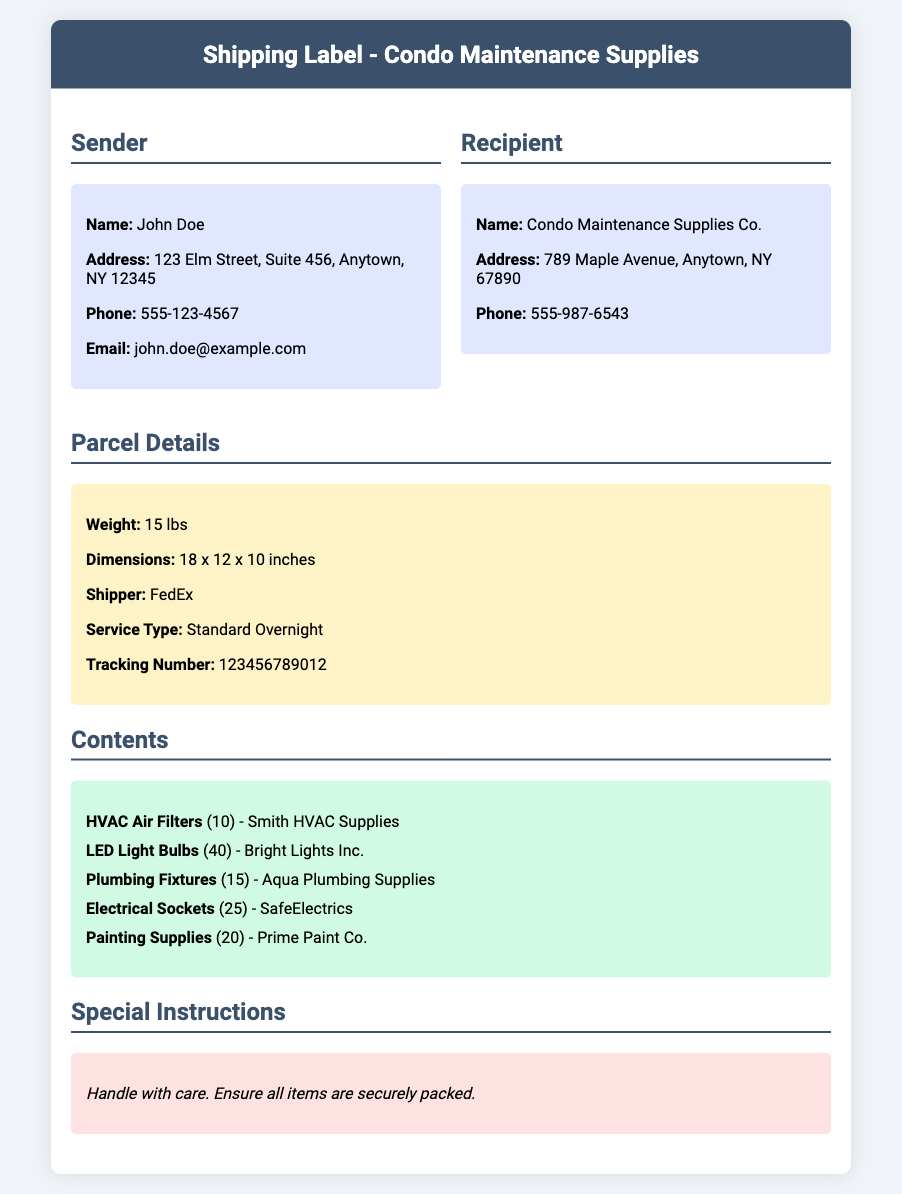What is the sender's name? The sender's name is provided in the document under the sender's section.
Answer: John Doe What is the recipient’s phone number? The recipient's phone number is listed under the recipient’s section.
Answer: 555-987-6543 What is the weight of the package? The weight of the package is mentioned in the parcel details section.
Answer: 15 lbs What company supplies the HVAC Air Filters? The supplier for the HVAC Air Filters is indicated in the contents section.
Answer: Smith HVAC Supplies How many plumbing fixtures are included in the shipment? The number of plumbing fixtures can be found in the contents section.
Answer: 15 What is the tracking number for the shipment? The tracking number is detailed in the parcel details section.
Answer: 123456789012 What service type is used for shipping? The service type for the shipment is noted in the parcel details.
Answer: Standard Overnight Identify one type of item included in the package. A type of item included in the package is mentioned in the contents section.
Answer: LED Light Bulbs What special instruction is given for the package? Special instructions about handling the package are provided at the bottom of the document.
Answer: Handle with care 